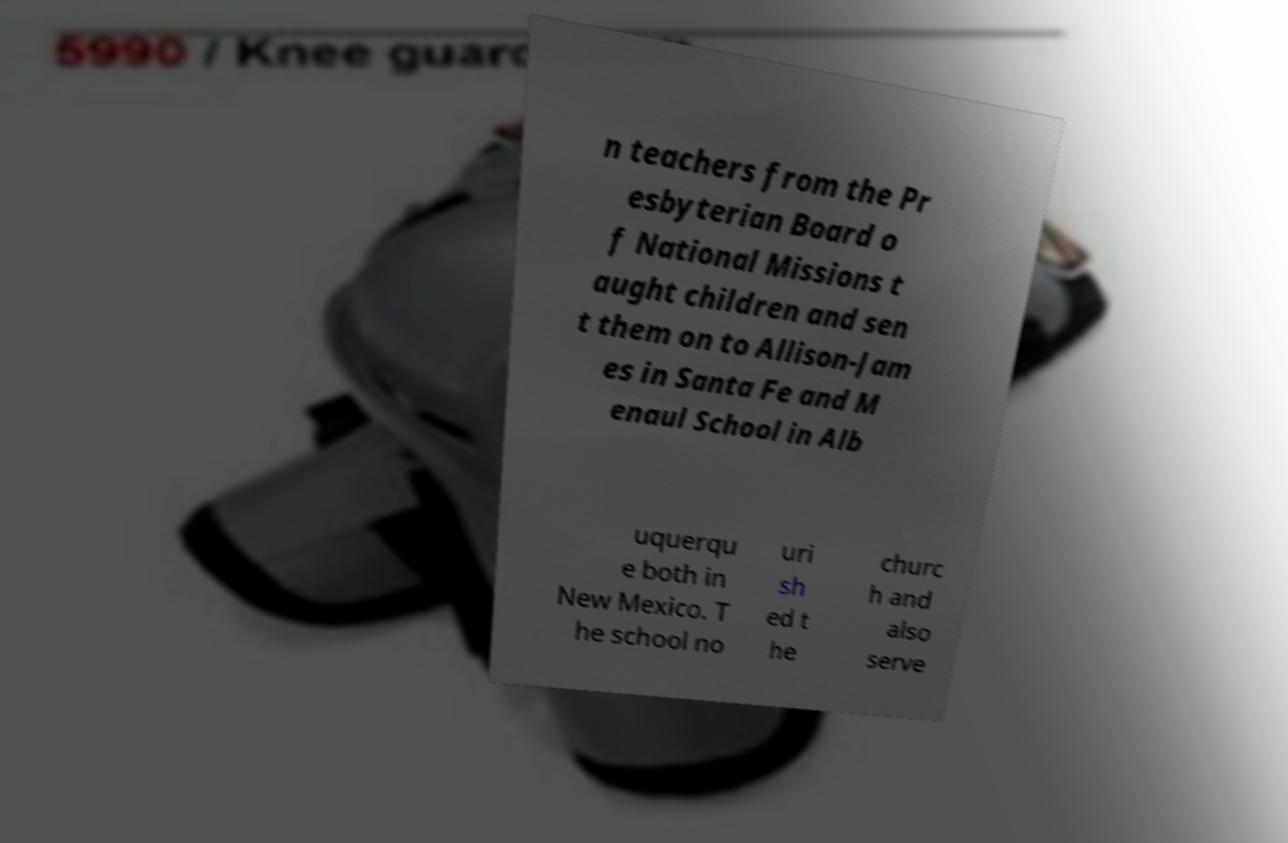Can you read and provide the text displayed in the image?This photo seems to have some interesting text. Can you extract and type it out for me? n teachers from the Pr esbyterian Board o f National Missions t aught children and sen t them on to Allison-Jam es in Santa Fe and M enaul School in Alb uquerqu e both in New Mexico. T he school no uri sh ed t he churc h and also serve 